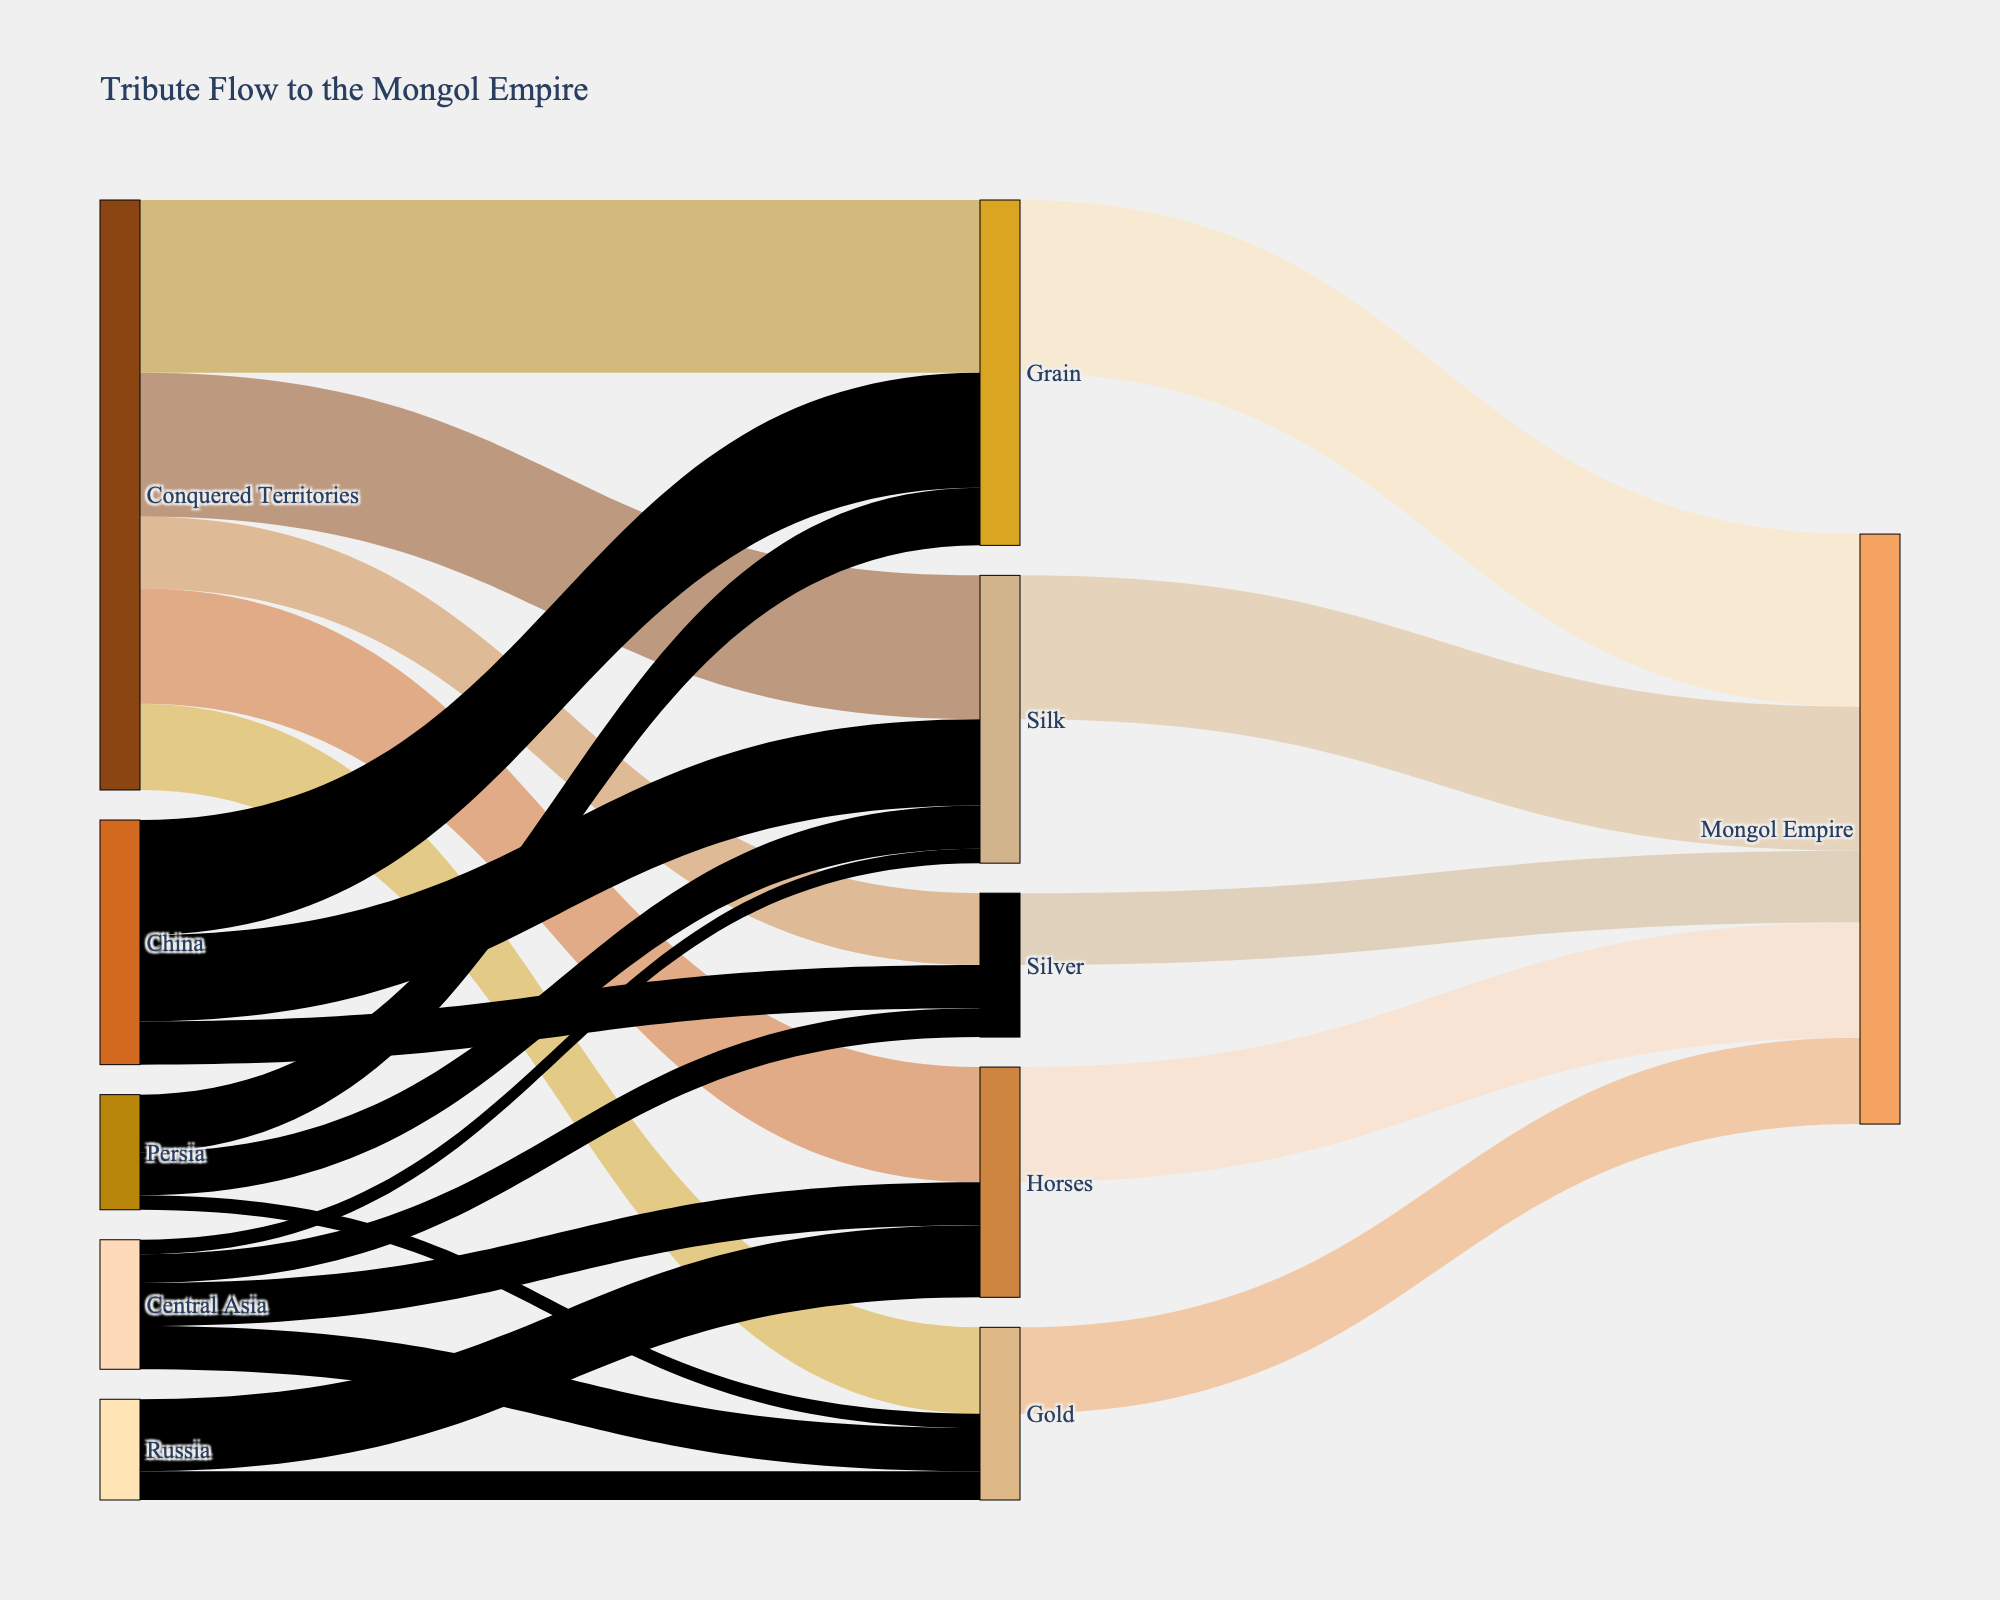What is the title of the diagram? The title of the diagram is typically located at the top of the figure and provides a brief summary of what the diagram represents. By referring to the figure, you can read the title text directly.
Answer: Tribute Flow to the Mongol Empire What are the resources mentioned in the diagram? To identify the resources mentioned, look at the nodes connecting the Conquered Territories to the Mongol Empire. The resources are distinct entities flowing from the Conquered Territories to the Empire.
Answer: Silk, Gold, Silver, Horses, Grain How much Silk was contributed to the Mongol Empire? Follow the flow from Silk to the Mongol Empire node. The value representing the amount of Silk is directly labeled along the path.
Answer: 5000 Which territory contributed the most Grain, and how much did it contribute? Trace the paths from the Grain to the originating territories. Compare the values to identify which territory has the highest contribution.
Answer: China, 4000 What is the total amount of tribute received by the Mongol Empire? Sum up all individual resource values connected directly to the Mongol Empire node. These are Silk (5000), Gold (3000), Silver (2500), Horses (4000), and Grain (6000). So, 5000 + 3000 + 2500 + 4000 + 6000.
Answer: 20500 Which resource had the largest overall contribution from the Conquered Territories? Compare the values of tribute in resources flowing out from the Conquered Territories node. Look for the highest numerical value.
Answer: Grain How much Gold was contributed by Central Asia? Locate the flow starting from Central Asia and ending at Gold. The value attached to this link represents the amount of Gold contributed by Central Asia.
Answer: 1500 Which resource has the least total contribution, and what is its value? Identify all resources contributed to the Mongol Empire and compare their values. The resource with the smallest value can be found this way.
Answer: Silver, 2500 How many regions contributed to Silk? Name them. Identify all connections leading to the Silk node from various regions. Count these connections and list the regions they originate from.
Answer: Three regions: China, Persia, Central Asia What is the total contribution value from Persia? Sum up all contributions from Persia by tracing all outgoing flows associated with Persia: Silk (1500), Gold (500), Grain (2000). So, 1500 + 500 + 2000.
Answer: 4000 